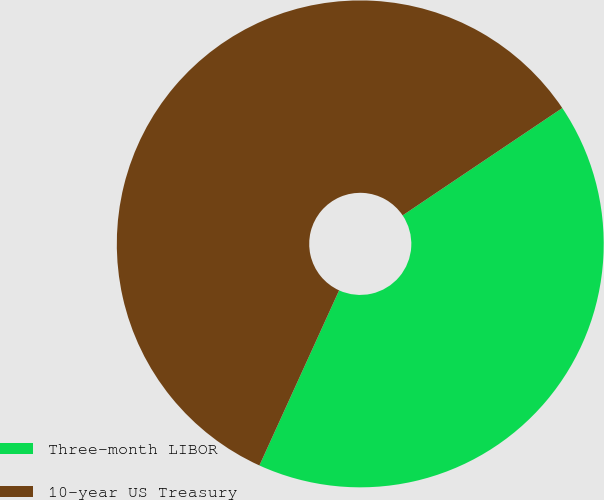<chart> <loc_0><loc_0><loc_500><loc_500><pie_chart><fcel>Three-month LIBOR<fcel>10-year US Treasury<nl><fcel>41.22%<fcel>58.78%<nl></chart> 